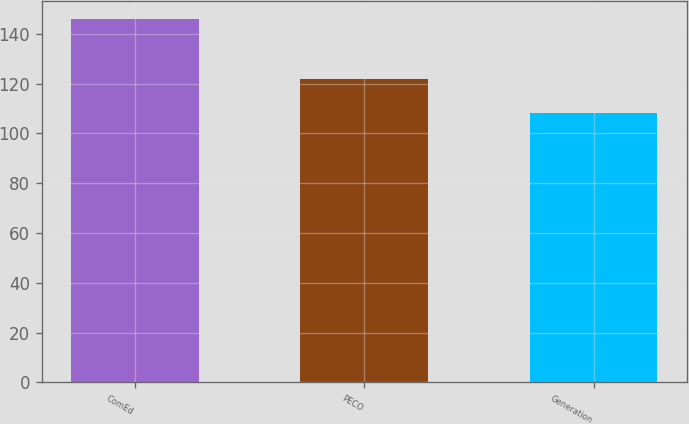Convert chart to OTSL. <chart><loc_0><loc_0><loc_500><loc_500><bar_chart><fcel>ComEd<fcel>PECO<fcel>Generation<nl><fcel>146<fcel>122<fcel>108<nl></chart> 